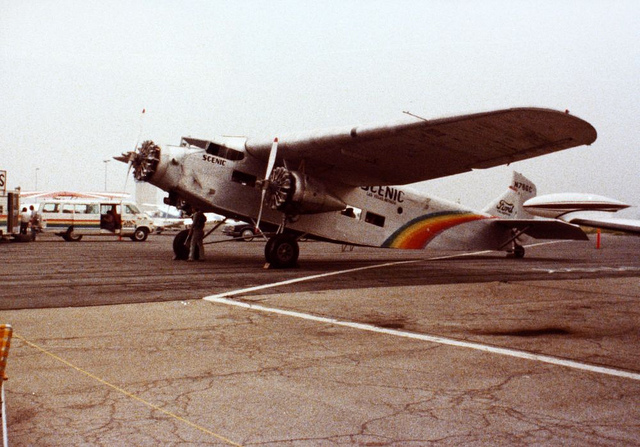<image>What number is the plane? I don't know the number of the plane. It could be '5', '1', '28', '886', 'n766c', 'm 7866', '2', or '5347'. What is the number on the front of the plane? It is unknown what the number on the front of the plane is. It could be '432', '100', '780', '20', 'm796c', 's300', or '27'. What is the number on the front of the plane? It is difficult to determine the number on the front of the plane. It could be any of the given options. What number is the plane? I don't know what number is the plane. It can be either '5', '1', '28', '886', 'n766c', 'm 7866', '2', or '5347'. 